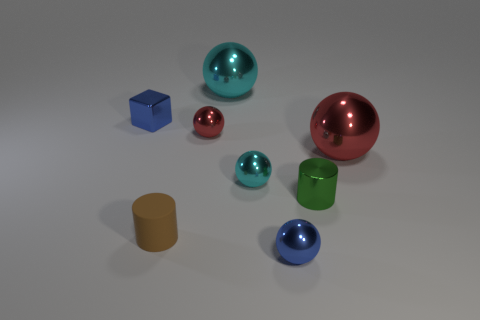Subtract all tiny blue metallic balls. How many balls are left? 4 Subtract all blue balls. How many balls are left? 4 Subtract all gray balls. Subtract all gray cubes. How many balls are left? 5 Add 2 tiny yellow blocks. How many objects exist? 10 Subtract all spheres. How many objects are left? 3 Add 4 tiny objects. How many tiny objects are left? 10 Add 5 tiny red metal objects. How many tiny red metal objects exist? 6 Subtract 0 gray balls. How many objects are left? 8 Subtract all cyan things. Subtract all big cyan objects. How many objects are left? 5 